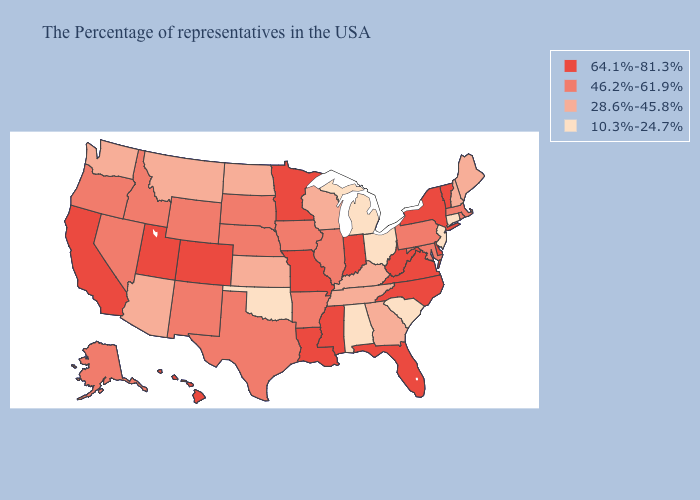What is the lowest value in states that border South Carolina?
Write a very short answer. 28.6%-45.8%. Among the states that border Wisconsin , does Michigan have the lowest value?
Keep it brief. Yes. Does South Carolina have the lowest value in the South?
Give a very brief answer. Yes. Does North Carolina have the highest value in the USA?
Give a very brief answer. Yes. What is the lowest value in the South?
Answer briefly. 10.3%-24.7%. What is the value of New York?
Keep it brief. 64.1%-81.3%. Does Vermont have the same value as Tennessee?
Be succinct. No. Is the legend a continuous bar?
Short answer required. No. Does Alabama have the lowest value in the USA?
Be succinct. Yes. Name the states that have a value in the range 10.3%-24.7%?
Quick response, please. Connecticut, New Jersey, South Carolina, Ohio, Michigan, Alabama, Oklahoma. Does Tennessee have a higher value than South Carolina?
Be succinct. Yes. Which states hav the highest value in the South?
Give a very brief answer. Delaware, Virginia, North Carolina, West Virginia, Florida, Mississippi, Louisiana. Does the first symbol in the legend represent the smallest category?
Concise answer only. No. What is the value of New Hampshire?
Concise answer only. 28.6%-45.8%. What is the value of Nebraska?
Keep it brief. 46.2%-61.9%. 